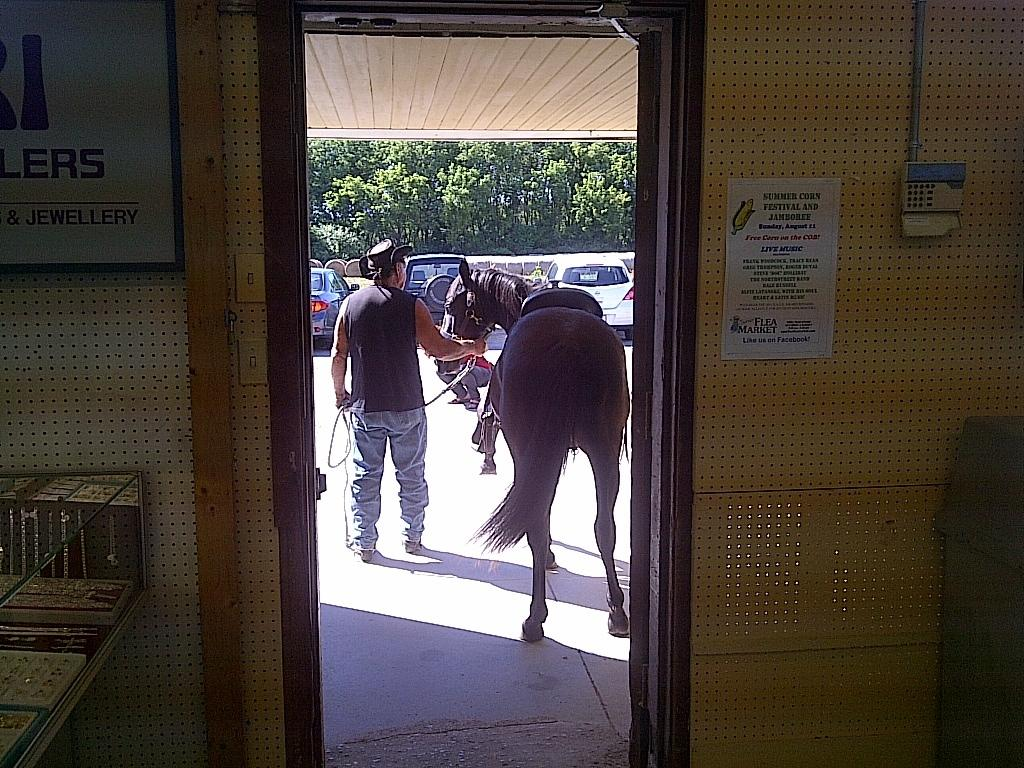What piece of furniture is located on the left side of the room? There is a desk on the left side of the room. What other feature can be found in the room? There is a door in the room. What is the man in the image doing? The man is holding a horse. What can be seen behind the man? There are cars behind the man. What is the fifth object in the room? There is no mention of a fifth object in the room, as only the desk, door, man, horse, and cars are described in the facts. What word is written on the door? There is no information about any words on the door in the provided facts. 